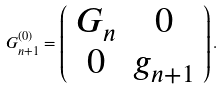<formula> <loc_0><loc_0><loc_500><loc_500>G _ { n + 1 } ^ { ( 0 ) } = \left ( \begin{array} { c c } G _ { n } & 0 \\ 0 & g _ { n + 1 } \end{array} \right ) .</formula> 